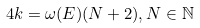<formula> <loc_0><loc_0><loc_500><loc_500>4 k = \omega ( E ) ( N + 2 ) , N \in \mathbb { N }</formula> 